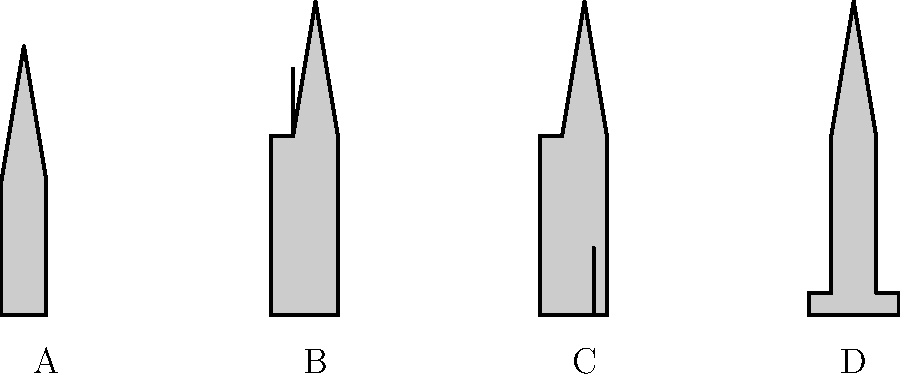As a coastal bed-and-breakfast proprietor with a keen eye for nautical themes, you're designing a new wall display featuring different sailboat silhouettes. Can you identify which silhouette represents a ketch? Let's examine each silhouette to identify the ketch:

1. Silhouette A: This shows a single mast with a triangular sail. This is characteristic of a sloop, which is the most common type of sailboat.

2. Silhouette B: This boat has two masts, with the shorter mast positioned forward of the rudder post. The main mast is taller and located more towards the center of the boat. This configuration is typical of a ketch.

3. Silhouette C: This also shows two masts, but the shorter mast is positioned behind the rudder post, near the stern of the boat. This arrangement is characteristic of a yawl.

4. Silhouette D: This silhouette shows a wide, flat profile with a single mast. This is indicative of a catamaran, which has two parallel hulls of equal size.

The key feature that distinguishes a ketch is its two-mast configuration, with the shorter mast (called the mizzen mast) positioned forward of the rudder post but still aft of the main mast. This perfectly describes Silhouette B.
Answer: B 